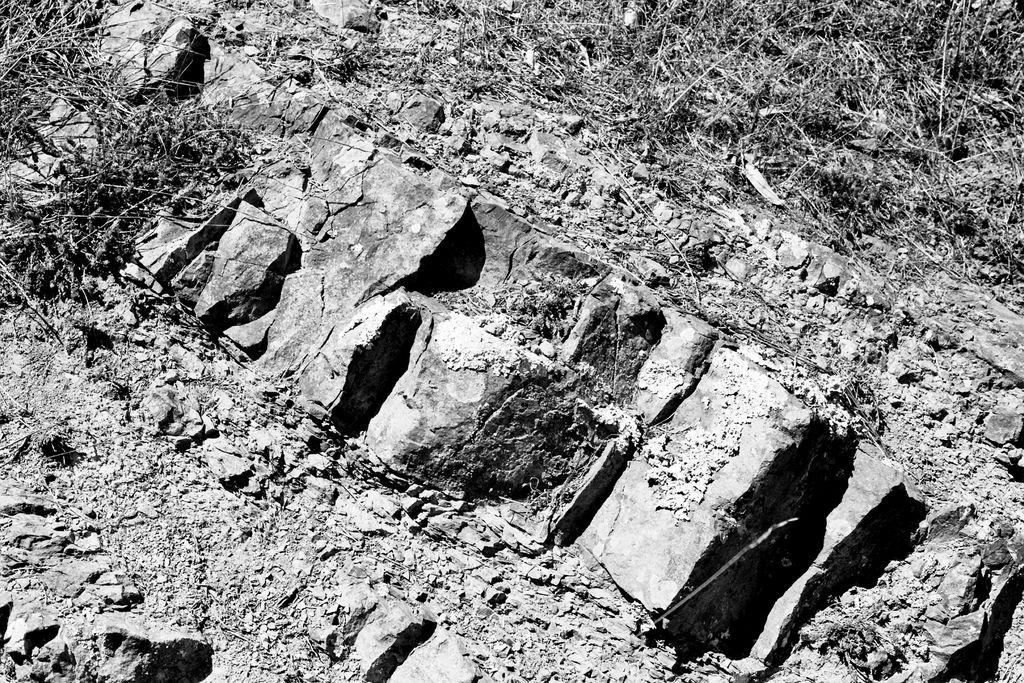What type of terrain is shown in the image? The image depicts a land. What can be seen on the ground in the image? There are stones and mud visible in the image. What type of vegetation is present in the image? There are plants in the image. What type of furniture can be seen in the image? There is no furniture present in the image; it depicts a land with stones, mud, and plants. 